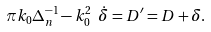<formula> <loc_0><loc_0><loc_500><loc_500>\pi k _ { 0 } \Delta ^ { - 1 } _ { n } - k _ { 0 } ^ { 2 } \ \dot { \delta } = D ^ { \prime } = D + \delta .</formula> 